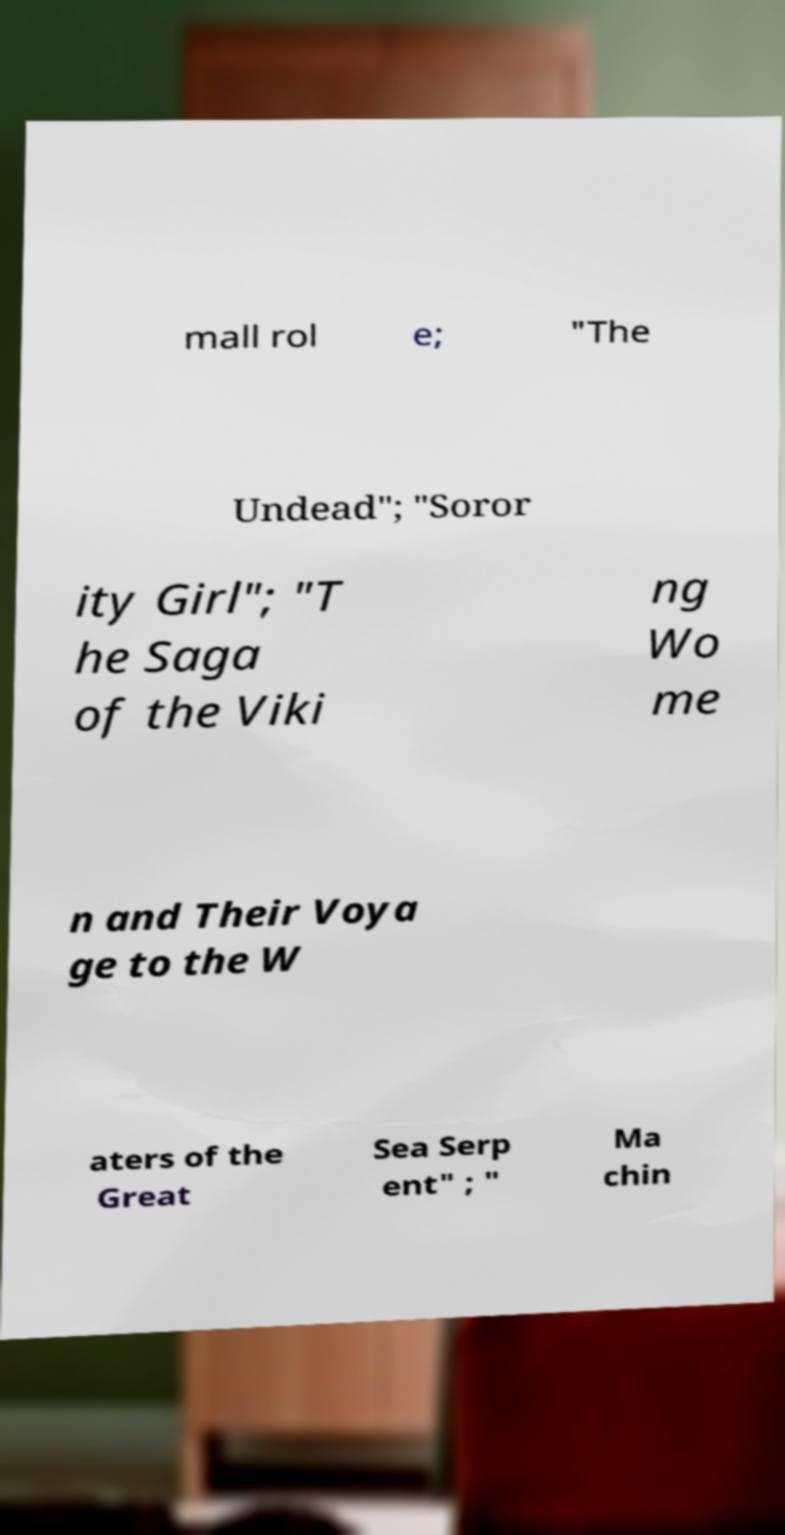I need the written content from this picture converted into text. Can you do that? mall rol e; "The Undead"; "Soror ity Girl"; "T he Saga of the Viki ng Wo me n and Their Voya ge to the W aters of the Great Sea Serp ent" ; " Ma chin 